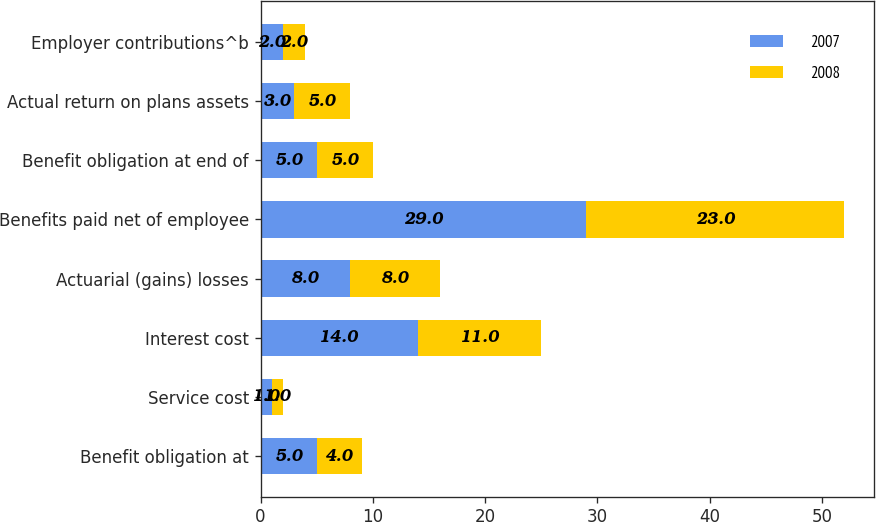<chart> <loc_0><loc_0><loc_500><loc_500><stacked_bar_chart><ecel><fcel>Benefit obligation at<fcel>Service cost<fcel>Interest cost<fcel>Actuarial (gains) losses<fcel>Benefits paid net of employee<fcel>Benefit obligation at end of<fcel>Actual return on plans assets<fcel>Employer contributions^b<nl><fcel>2007<fcel>5<fcel>1<fcel>14<fcel>8<fcel>29<fcel>5<fcel>3<fcel>2<nl><fcel>2008<fcel>4<fcel>1<fcel>11<fcel>8<fcel>23<fcel>5<fcel>5<fcel>2<nl></chart> 